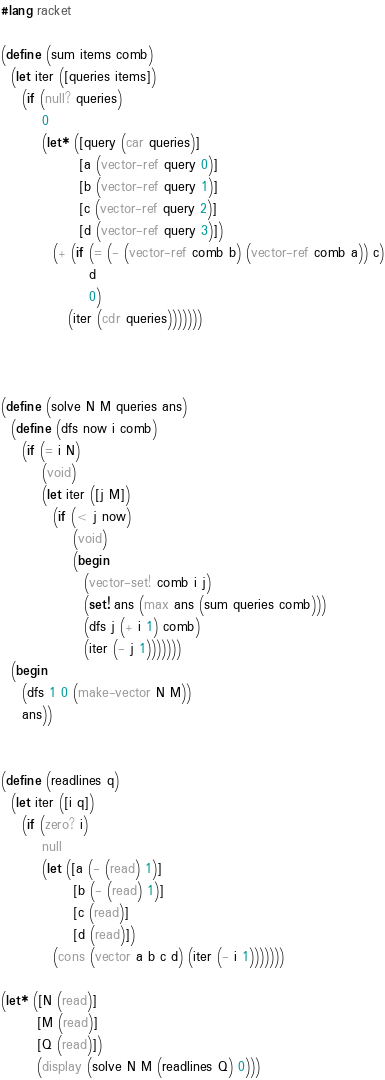Convert code to text. <code><loc_0><loc_0><loc_500><loc_500><_Racket_>#lang racket

(define (sum items comb)
  (let iter ([queries items])
    (if (null? queries)
        0
        (let* ([query (car queries)]
               [a (vector-ref query 0)]
               [b (vector-ref query 1)]
               [c (vector-ref query 2)]
               [d (vector-ref query 3)])
          (+ (if (= (- (vector-ref comb b) (vector-ref comb a)) c)
                 d
                 0)
             (iter (cdr queries)))))))

           
          
(define (solve N M queries ans)
  (define (dfs now i comb)
    (if (= i N)
        (void)
        (let iter ([j M])
          (if (< j now)
              (void)
              (begin
                (vector-set! comb i j)
                (set! ans (max ans (sum queries comb)))
                (dfs j (+ i 1) comb)
                (iter (- j 1)))))))
  (begin
    (dfs 1 0 (make-vector N M))
    ans))
          
          
(define (readlines q)
  (let iter ([i q])
    (if (zero? i)
        null
        (let ([a (- (read) 1)]
              [b (- (read) 1)]
              [c (read)]
              [d (read)])
          (cons (vector a b c d) (iter (- i 1)))))))

(let* ([N (read)]
       [M (read)]
       [Q (read)])
       (display (solve N M (readlines Q) 0)))</code> 